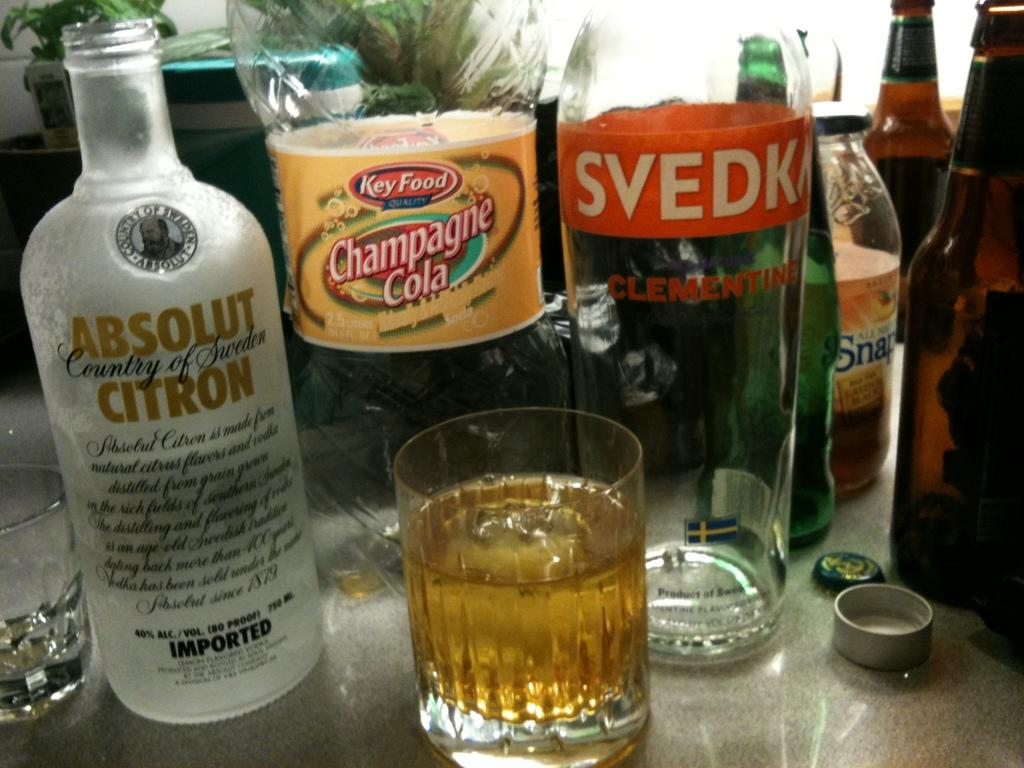<image>
Present a compact description of the photo's key features. An open bottle of Absolut Citron next to a full glass and bottles of Champagne Cola. 